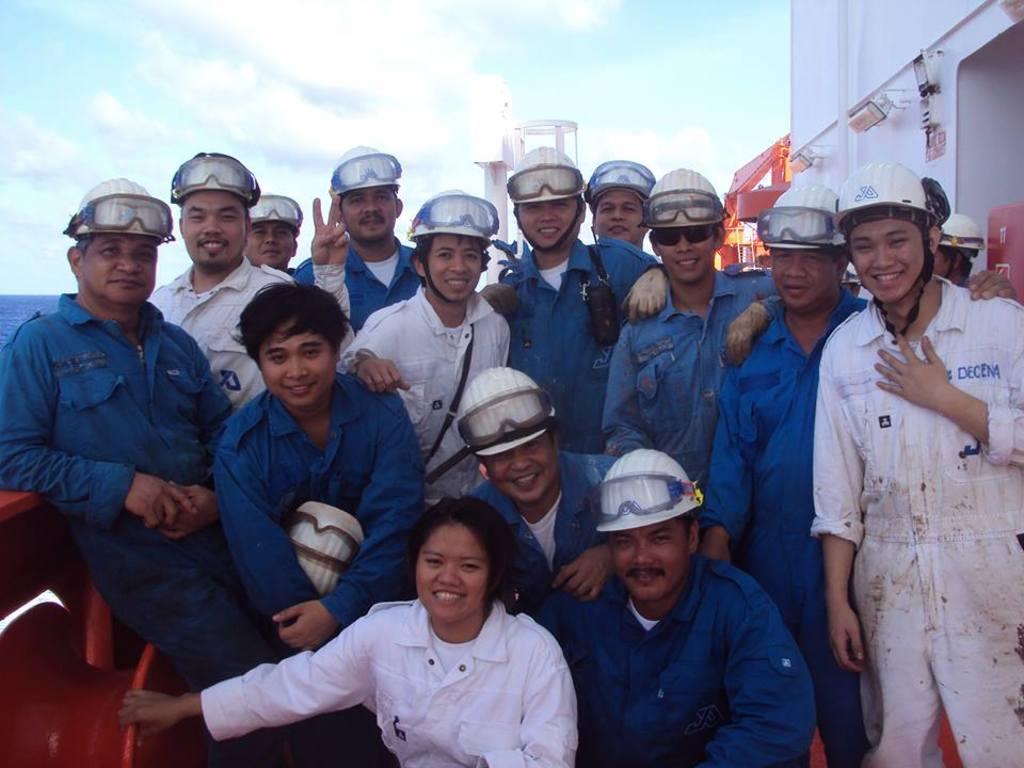How would you summarize this image in a sentence or two? In the front of the image there are people and an object. People wore helmets and goggles. In the background of the image there is water, cloudy sky, wall, lights and objects. 